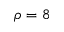Convert formula to latex. <formula><loc_0><loc_0><loc_500><loc_500>\rho = 8</formula> 